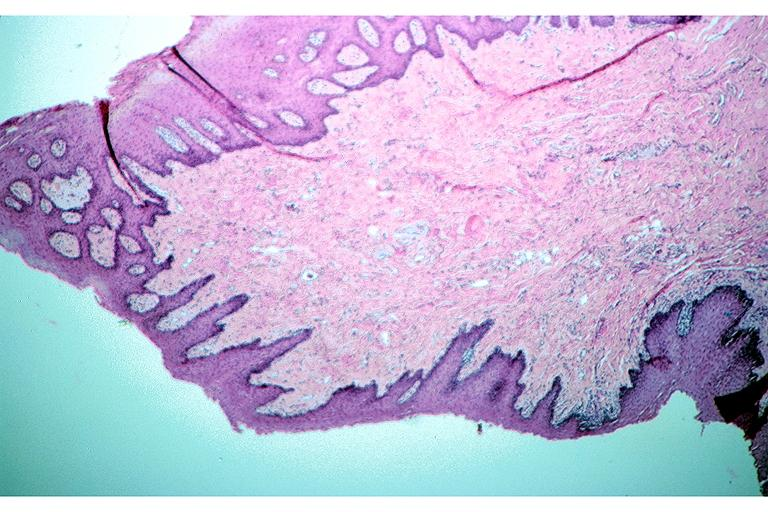does this image show irritation fibroma?
Answer the question using a single word or phrase. Yes 